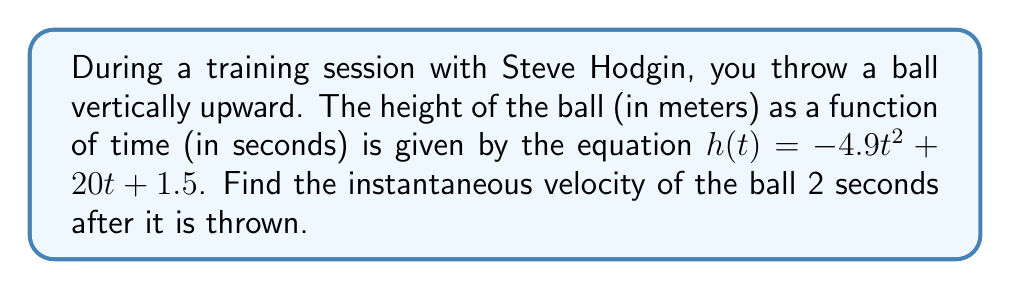Can you solve this math problem? To find the instantaneous velocity, we need to calculate the derivative of the position function and evaluate it at the given time.

1) The height function is given as:
   $h(t) = -4.9t^2 + 20t + 1.5$

2) The velocity function is the derivative of the height function:
   $v(t) = \frac{d}{dt}h(t) = -9.8t + 20$

3) To find the instantaneous velocity at t = 2 seconds, we substitute t = 2 into the velocity function:

   $v(2) = -9.8(2) + 20$
   $v(2) = -19.6 + 20$
   $v(2) = 0.4$

4) The units for velocity are meters per second (m/s).

Therefore, the instantaneous velocity of the ball 2 seconds after it is thrown is 0.4 m/s upward.
Answer: 0.4 m/s upward 